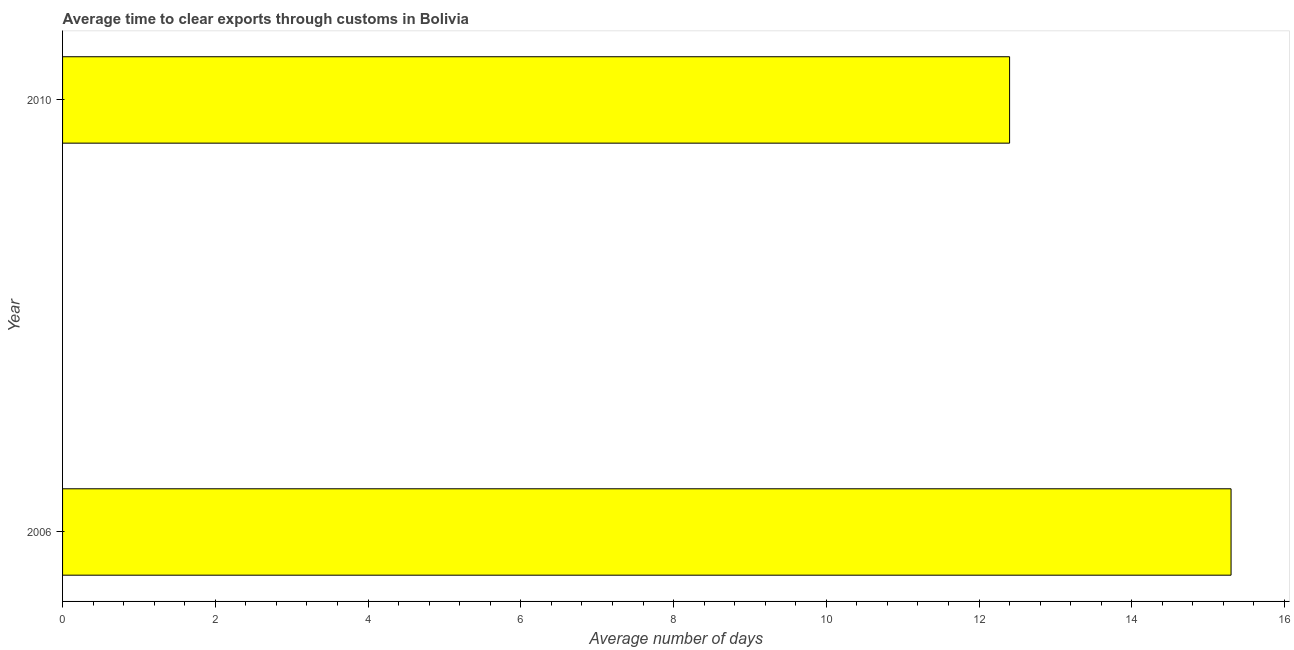What is the title of the graph?
Offer a terse response. Average time to clear exports through customs in Bolivia. What is the label or title of the X-axis?
Provide a short and direct response. Average number of days. What is the label or title of the Y-axis?
Your response must be concise. Year. What is the time to clear exports through customs in 2006?
Your answer should be very brief. 15.3. Across all years, what is the maximum time to clear exports through customs?
Provide a short and direct response. 15.3. What is the sum of the time to clear exports through customs?
Keep it short and to the point. 27.7. What is the difference between the time to clear exports through customs in 2006 and 2010?
Provide a succinct answer. 2.9. What is the average time to clear exports through customs per year?
Provide a short and direct response. 13.85. What is the median time to clear exports through customs?
Ensure brevity in your answer.  13.85. In how many years, is the time to clear exports through customs greater than 1.2 days?
Ensure brevity in your answer.  2. What is the ratio of the time to clear exports through customs in 2006 to that in 2010?
Offer a terse response. 1.23. Is the time to clear exports through customs in 2006 less than that in 2010?
Ensure brevity in your answer.  No. Are all the bars in the graph horizontal?
Give a very brief answer. Yes. How many years are there in the graph?
Your response must be concise. 2. Are the values on the major ticks of X-axis written in scientific E-notation?
Keep it short and to the point. No. What is the Average number of days in 2010?
Give a very brief answer. 12.4. What is the difference between the Average number of days in 2006 and 2010?
Offer a very short reply. 2.9. What is the ratio of the Average number of days in 2006 to that in 2010?
Your answer should be very brief. 1.23. 